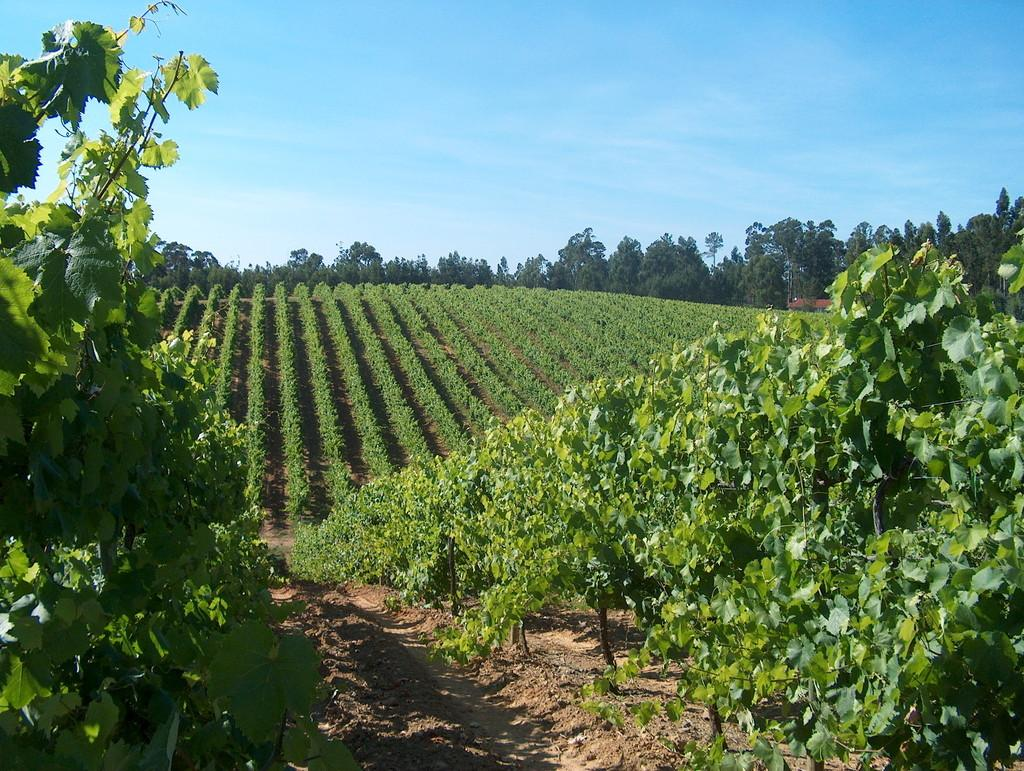What type of natural environment is depicted in the image? There is greenery in the image, suggesting a natural environment. Can you describe any specific features of the landscape? There is a path at the bottom side of the image. How many icicles can be seen hanging from the trees in the image? There are no icicles present in the image, as it features greenery and a path, which typically do not have icicles. 